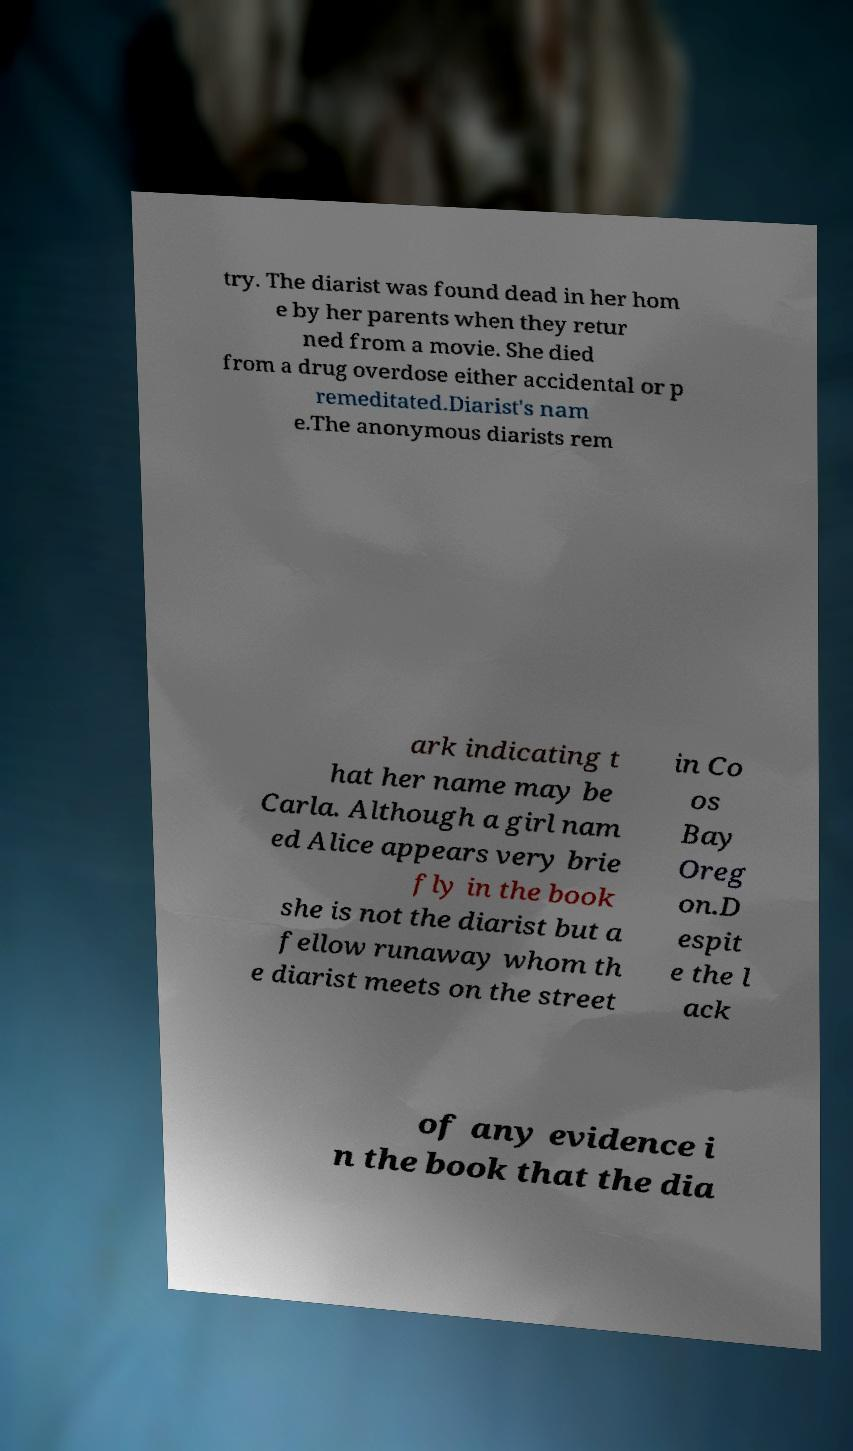Could you extract and type out the text from this image? try. The diarist was found dead in her hom e by her parents when they retur ned from a movie. She died from a drug overdose either accidental or p remeditated.Diarist's nam e.The anonymous diarists rem ark indicating t hat her name may be Carla. Although a girl nam ed Alice appears very brie fly in the book she is not the diarist but a fellow runaway whom th e diarist meets on the street in Co os Bay Oreg on.D espit e the l ack of any evidence i n the book that the dia 